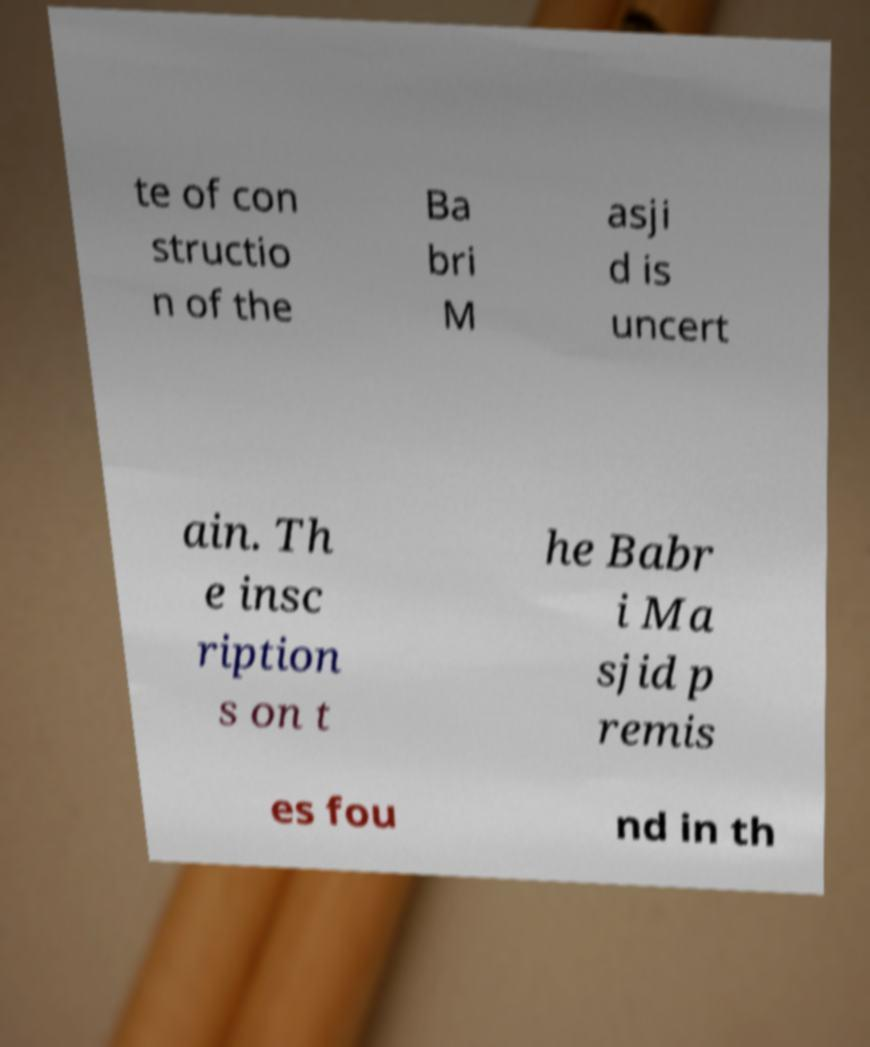Could you assist in decoding the text presented in this image and type it out clearly? te of con structio n of the Ba bri M asji d is uncert ain. Th e insc ription s on t he Babr i Ma sjid p remis es fou nd in th 